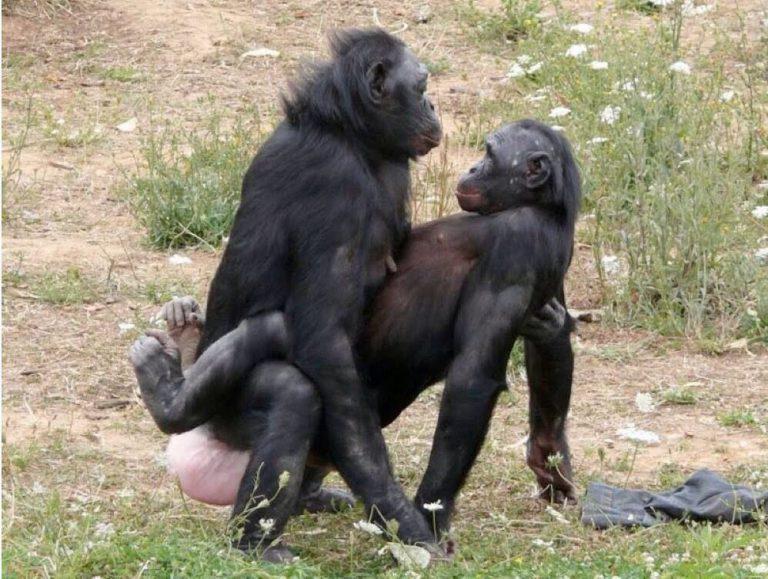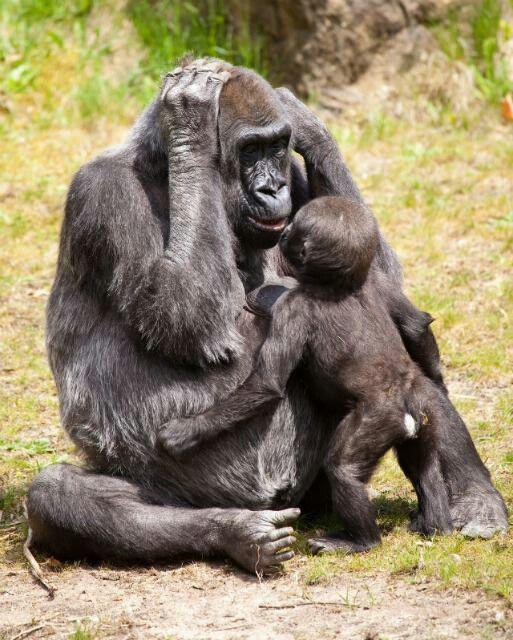The first image is the image on the left, the second image is the image on the right. Examine the images to the left and right. Is the description "There are exactly three gorillas." accurate? Answer yes or no. No. The first image is the image on the left, the second image is the image on the right. Given the left and right images, does the statement "A baby gorilla is in front of a sitting adult gorilla with both hands touching its head, in one image." hold true? Answer yes or no. Yes. 